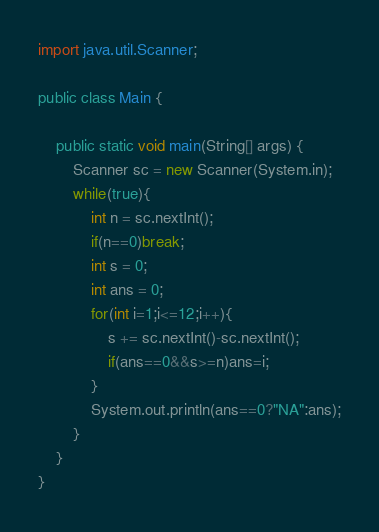<code> <loc_0><loc_0><loc_500><loc_500><_Java_>import java.util.Scanner;

public class Main {

	public static void main(String[] args) {
		Scanner sc = new Scanner(System.in);
		while(true){
			int n = sc.nextInt();
			if(n==0)break;
			int s = 0;
			int ans = 0;
			for(int i=1;i<=12;i++){
				s += sc.nextInt()-sc.nextInt();
				if(ans==0&&s>=n)ans=i;
			}
			System.out.println(ans==0?"NA":ans);
		}
	}
}</code> 